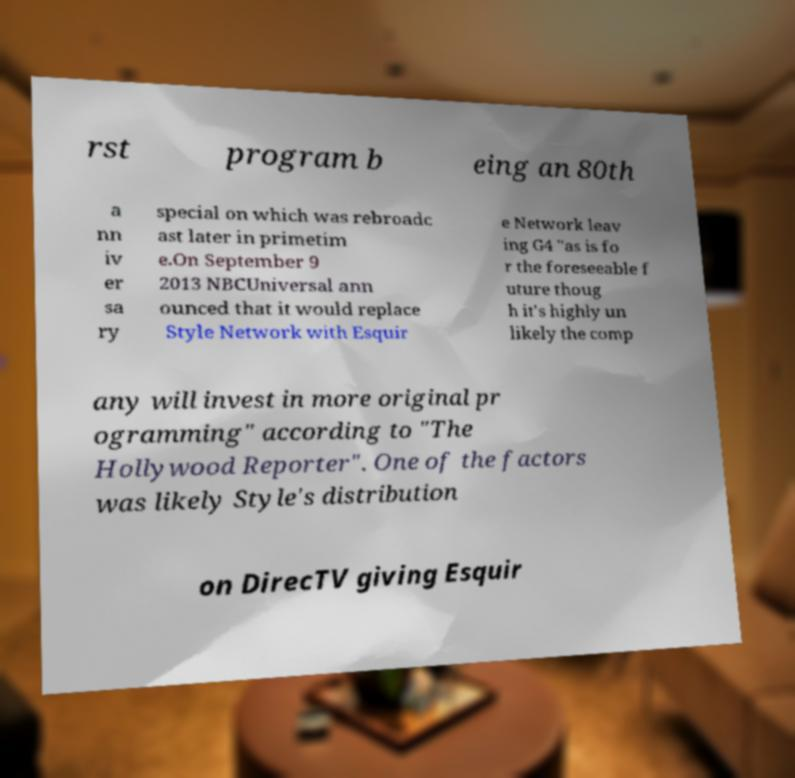For documentation purposes, I need the text within this image transcribed. Could you provide that? rst program b eing an 80th a nn iv er sa ry special on which was rebroadc ast later in primetim e.On September 9 2013 NBCUniversal ann ounced that it would replace Style Network with Esquir e Network leav ing G4 "as is fo r the foreseeable f uture thoug h it's highly un likely the comp any will invest in more original pr ogramming" according to "The Hollywood Reporter". One of the factors was likely Style's distribution on DirecTV giving Esquir 